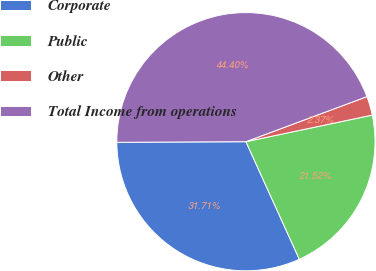Convert chart to OTSL. <chart><loc_0><loc_0><loc_500><loc_500><pie_chart><fcel>Corporate<fcel>Public<fcel>Other<fcel>Total Income from operations<nl><fcel>31.71%<fcel>21.52%<fcel>2.37%<fcel>44.4%<nl></chart> 